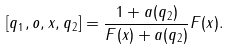<formula> <loc_0><loc_0><loc_500><loc_500>[ q _ { 1 } , o , x , q _ { 2 } ] = \frac { 1 + a ( q _ { 2 } ) } { F ( x ) + a ( q _ { 2 } ) } F ( x ) .</formula> 